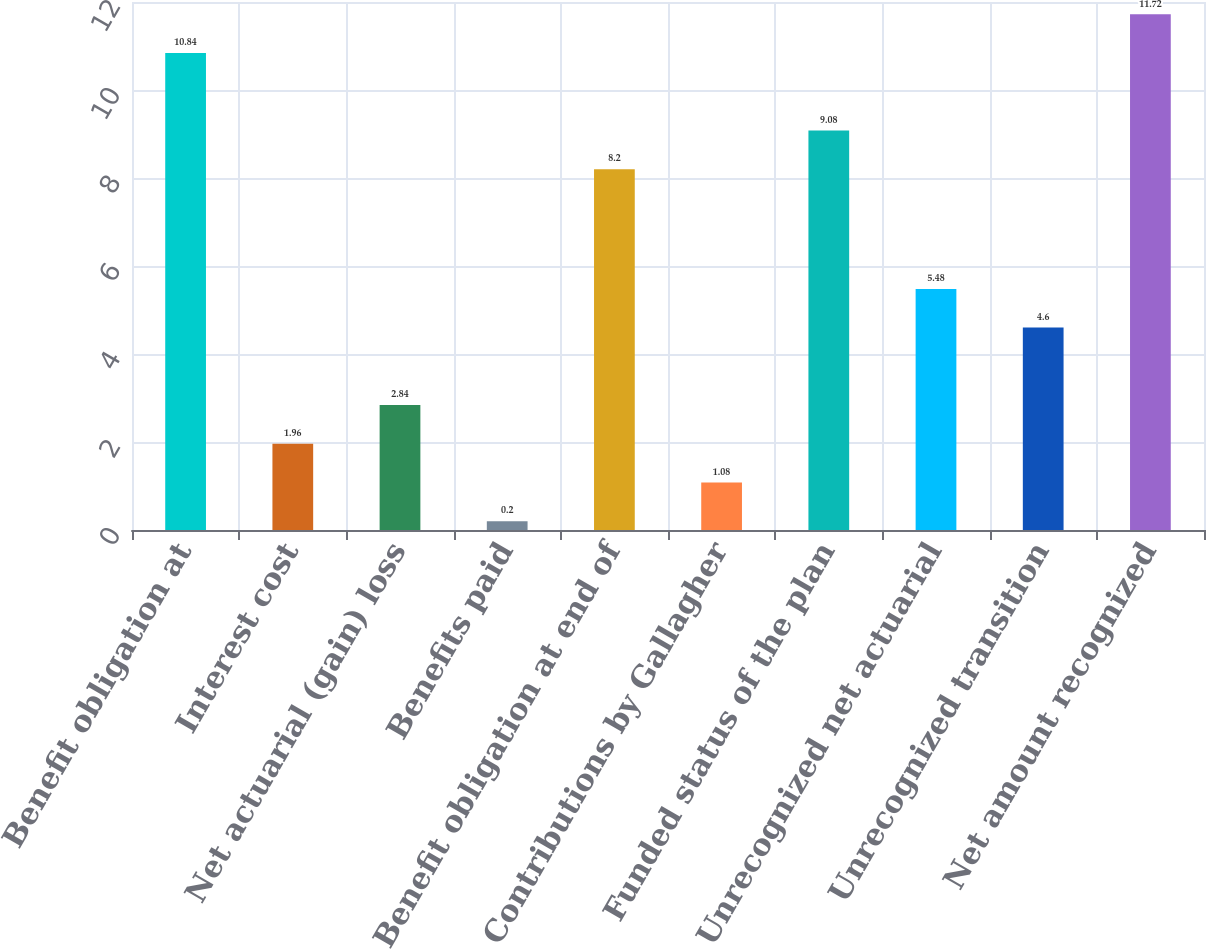Convert chart. <chart><loc_0><loc_0><loc_500><loc_500><bar_chart><fcel>Benefit obligation at<fcel>Interest cost<fcel>Net actuarial (gain) loss<fcel>Benefits paid<fcel>Benefit obligation at end of<fcel>Contributions by Gallagher<fcel>Funded status of the plan<fcel>Unrecognized net actuarial<fcel>Unrecognized transition<fcel>Net amount recognized<nl><fcel>10.84<fcel>1.96<fcel>2.84<fcel>0.2<fcel>8.2<fcel>1.08<fcel>9.08<fcel>5.48<fcel>4.6<fcel>11.72<nl></chart> 